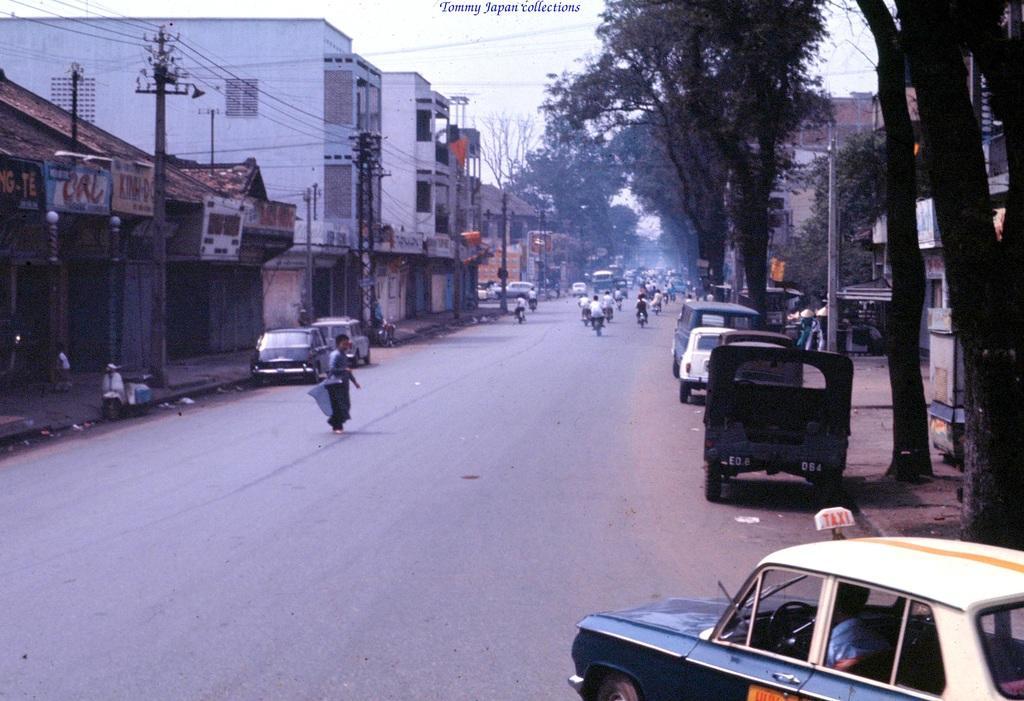Please provide a concise description of this image. In this image we can see the view of a street. In the street there are buildings, electric poles, electric cables, name boards, stalls, motor vehicles on the road, persons walking, trees and sky. 